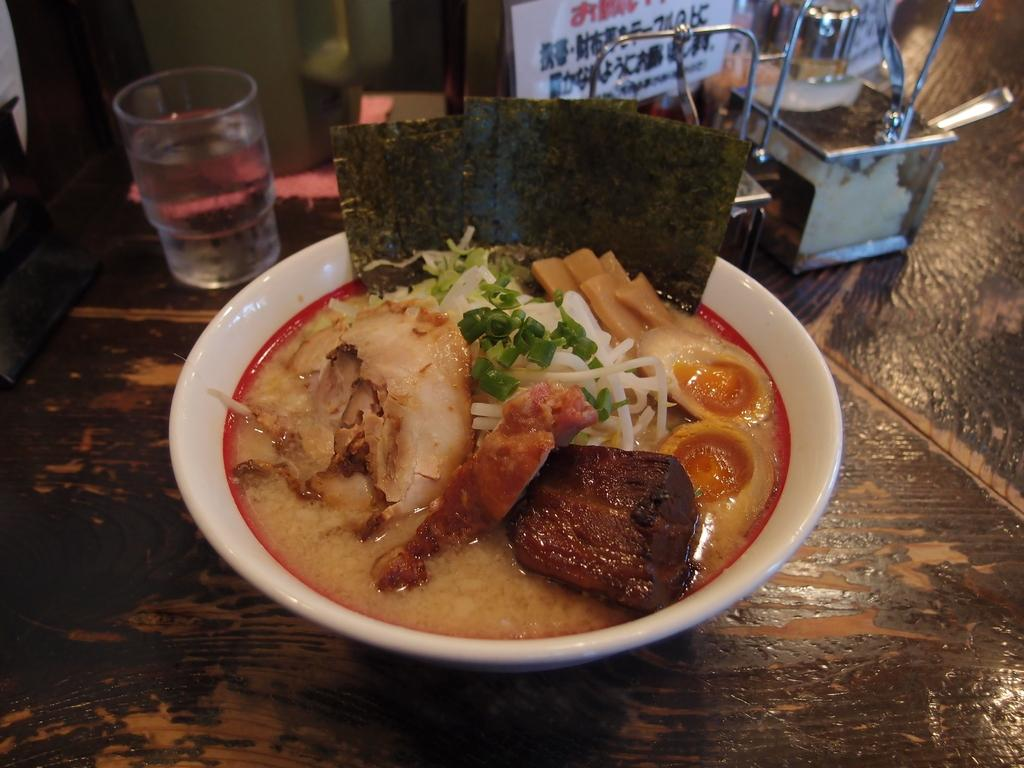What is located in the center of the image? There is a table in the center of the image. What is placed on the table? There is a bowl of food items and a glass of water on the table. What utensils are present on the table? There are spoons on the table. What else can be seen on the table? There are some vessels on the table. What type of pollution can be seen in the image? There is no pollution present in the image; it features a table with various items on it. Are there any signs of destruction in the image? There are no signs of destruction present in the image; it features a table with various items on it. 